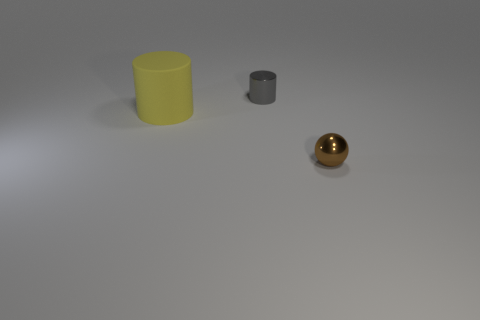Is there anything else that is the same size as the yellow rubber cylinder?
Provide a short and direct response. No. The yellow cylinder has what size?
Give a very brief answer. Large. There is a thing that is to the left of the tiny gray cylinder; how big is it?
Offer a very short reply. Large. The large yellow object is what shape?
Keep it short and to the point. Cylinder. There is a cylinder right of the yellow matte thing; what material is it?
Your response must be concise. Metal. There is a tiny object that is in front of the cylinder that is on the left side of the tiny object behind the big matte thing; what is its color?
Offer a very short reply. Brown. There is a thing that is the same size as the brown metal ball; what color is it?
Make the answer very short. Gray. How many matte things are either small green balls or large things?
Your response must be concise. 1. What is the color of the thing that is made of the same material as the tiny sphere?
Make the answer very short. Gray. There is a small ball to the right of the small metallic object that is behind the small brown ball; what is it made of?
Make the answer very short. Metal. 